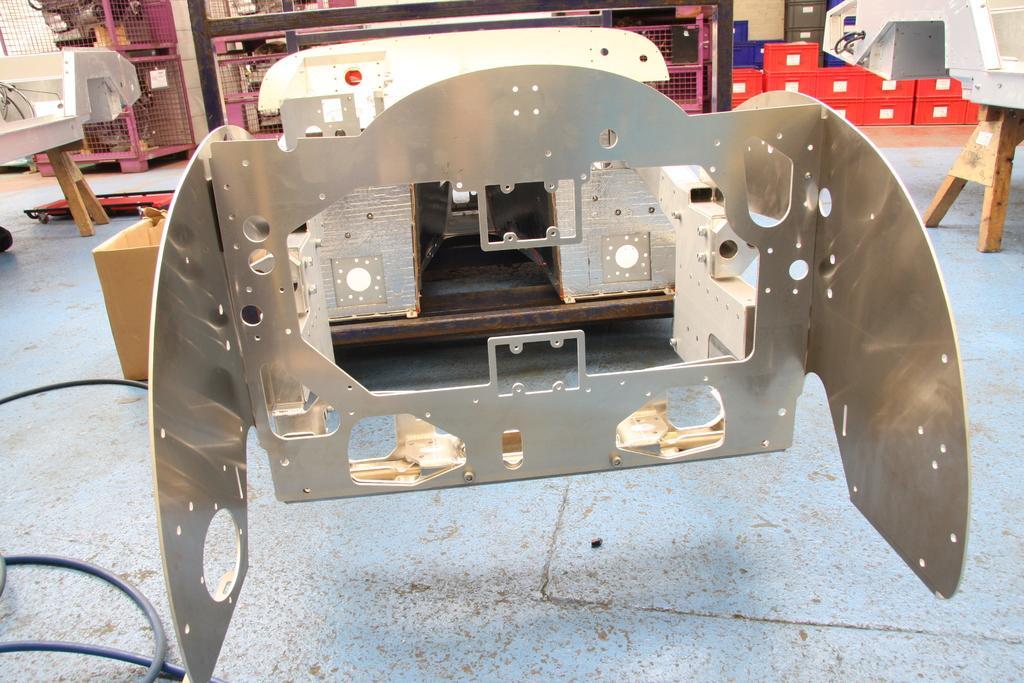Please provide a concise description of this image. In the middle of the image we can see some tables, on the tables we can see some objects. Behind the tables we can see some boxes. 